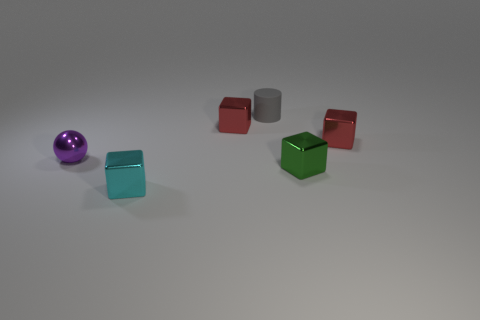Subtract 1 blocks. How many blocks are left? 3 Subtract all yellow cubes. Subtract all blue spheres. How many cubes are left? 4 Add 1 tiny cyan blocks. How many objects exist? 7 Subtract all balls. How many objects are left? 5 Add 6 red things. How many red things are left? 8 Add 5 metal objects. How many metal objects exist? 10 Subtract 0 red balls. How many objects are left? 6 Subtract all small cyan cubes. Subtract all red things. How many objects are left? 3 